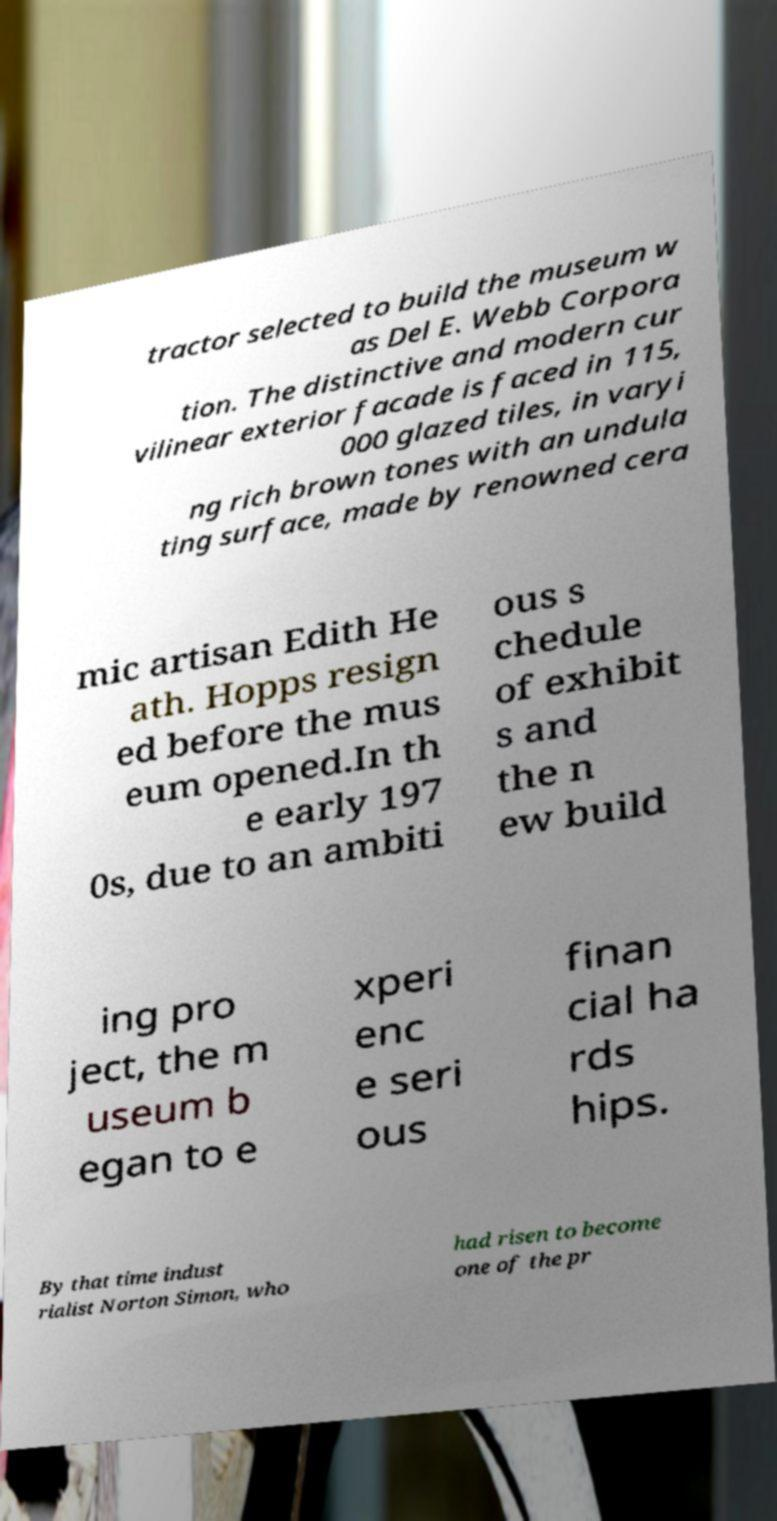For documentation purposes, I need the text within this image transcribed. Could you provide that? tractor selected to build the museum w as Del E. Webb Corpora tion. The distinctive and modern cur vilinear exterior facade is faced in 115, 000 glazed tiles, in varyi ng rich brown tones with an undula ting surface, made by renowned cera mic artisan Edith He ath. Hopps resign ed before the mus eum opened.In th e early 197 0s, due to an ambiti ous s chedule of exhibit s and the n ew build ing pro ject, the m useum b egan to e xperi enc e seri ous finan cial ha rds hips. By that time indust rialist Norton Simon, who had risen to become one of the pr 